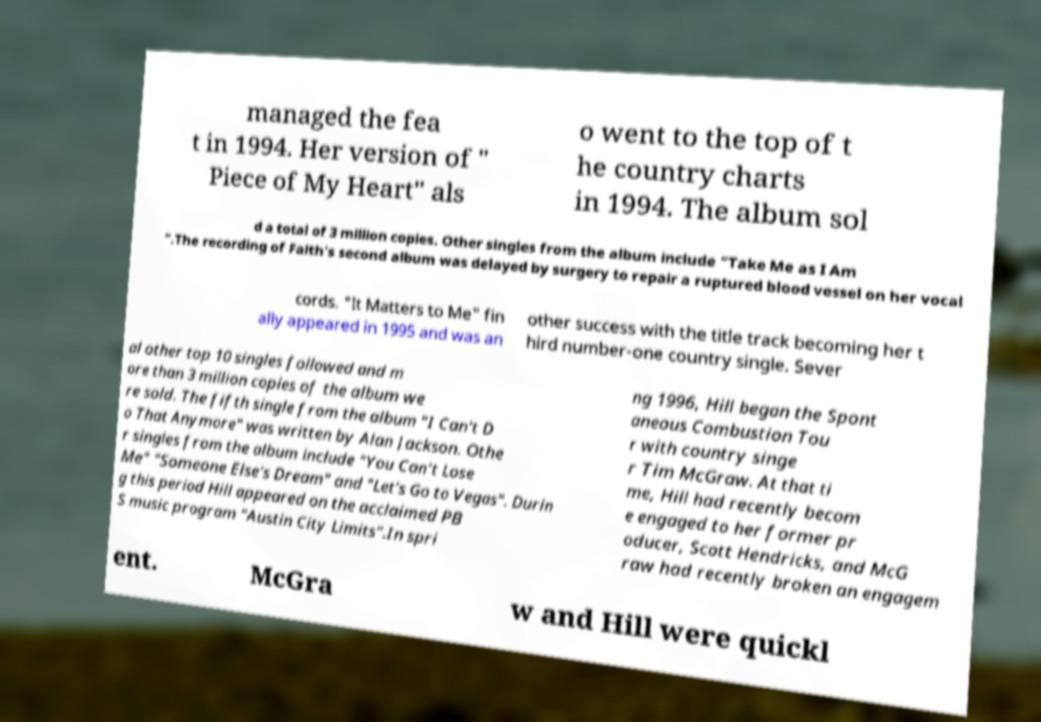There's text embedded in this image that I need extracted. Can you transcribe it verbatim? managed the fea t in 1994. Her version of " Piece of My Heart" als o went to the top of t he country charts in 1994. The album sol d a total of 3 million copies. Other singles from the album include "Take Me as I Am ".The recording of Faith's second album was delayed by surgery to repair a ruptured blood vessel on her vocal cords. "It Matters to Me" fin ally appeared in 1995 and was an other success with the title track becoming her t hird number-one country single. Sever al other top 10 singles followed and m ore than 3 million copies of the album we re sold. The fifth single from the album "I Can't D o That Anymore" was written by Alan Jackson. Othe r singles from the album include "You Can't Lose Me" "Someone Else's Dream" and "Let's Go to Vegas". Durin g this period Hill appeared on the acclaimed PB S music program "Austin City Limits".In spri ng 1996, Hill began the Spont aneous Combustion Tou r with country singe r Tim McGraw. At that ti me, Hill had recently becom e engaged to her former pr oducer, Scott Hendricks, and McG raw had recently broken an engagem ent. McGra w and Hill were quickl 